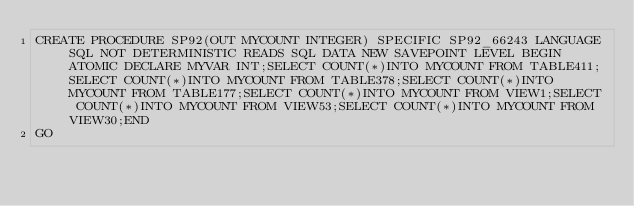<code> <loc_0><loc_0><loc_500><loc_500><_SQL_>CREATE PROCEDURE SP92(OUT MYCOUNT INTEGER) SPECIFIC SP92_66243 LANGUAGE SQL NOT DETERMINISTIC READS SQL DATA NEW SAVEPOINT LEVEL BEGIN ATOMIC DECLARE MYVAR INT;SELECT COUNT(*)INTO MYCOUNT FROM TABLE411;SELECT COUNT(*)INTO MYCOUNT FROM TABLE378;SELECT COUNT(*)INTO MYCOUNT FROM TABLE177;SELECT COUNT(*)INTO MYCOUNT FROM VIEW1;SELECT COUNT(*)INTO MYCOUNT FROM VIEW53;SELECT COUNT(*)INTO MYCOUNT FROM VIEW30;END
GO</code> 